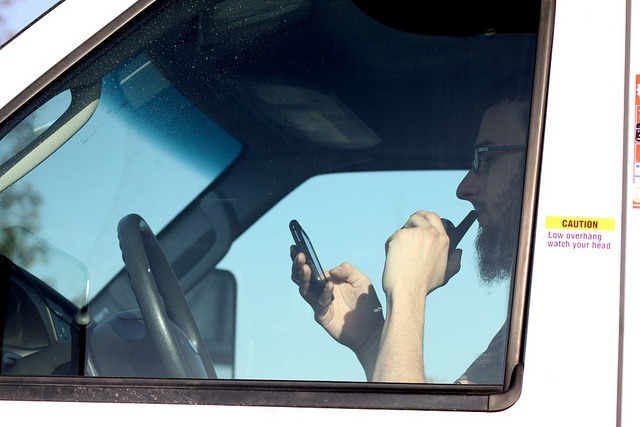Describe the objects in this image and their specific colors. I can see car in lavender, black, lightblue, blue, and gray tones, people in lavender, gray, tan, black, and darkblue tones, and cell phone in lavender, blue, darkblue, gray, and navy tones in this image. 